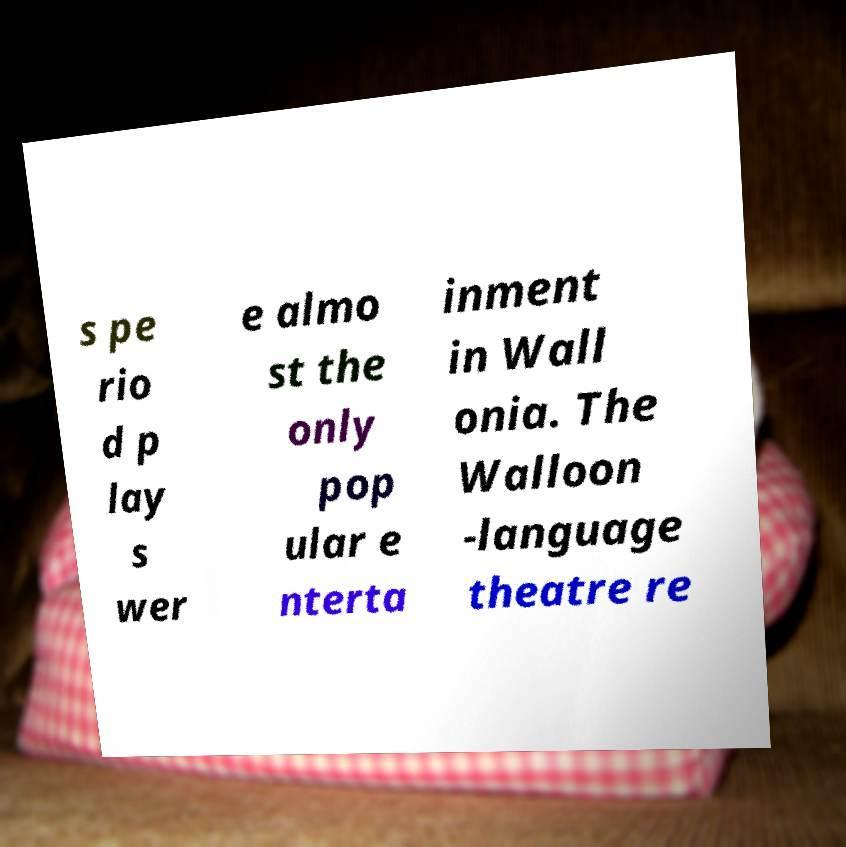Can you accurately transcribe the text from the provided image for me? s pe rio d p lay s wer e almo st the only pop ular e nterta inment in Wall onia. The Walloon -language theatre re 